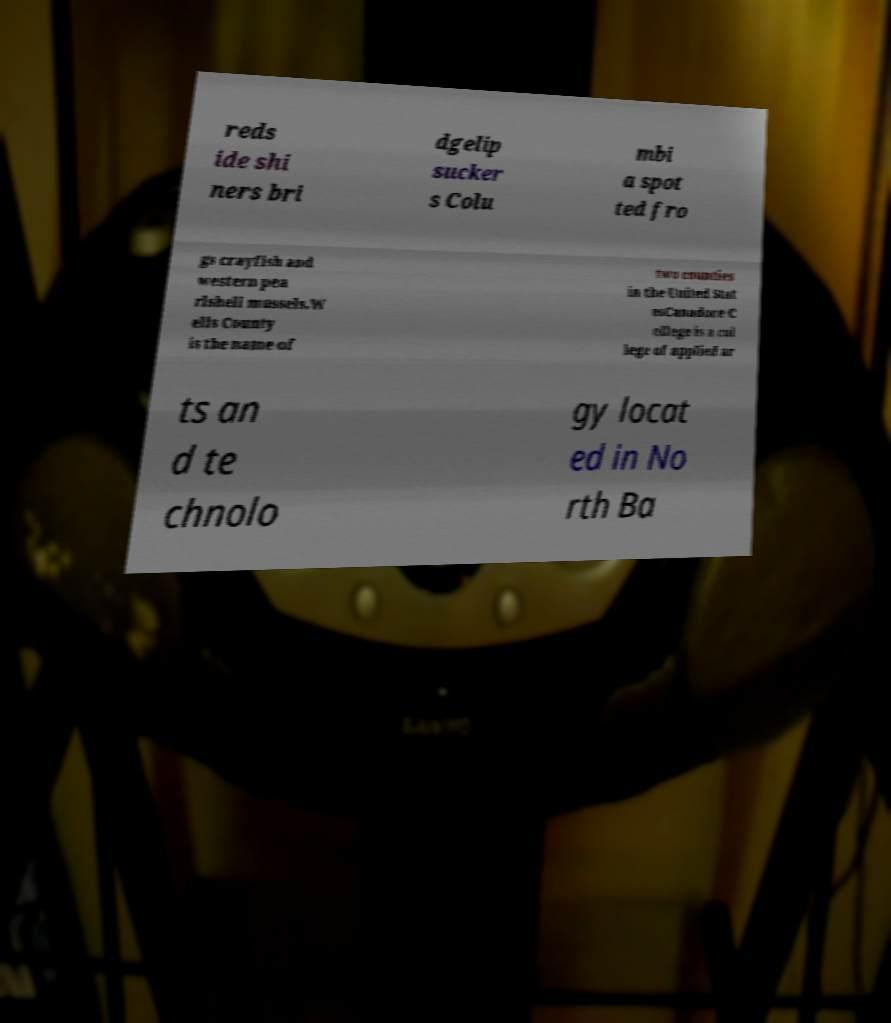Can you accurately transcribe the text from the provided image for me? reds ide shi ners bri dgelip sucker s Colu mbi a spot ted fro gs crayfish and western pea rlshell mussels.W ells County is the name of two counties in the United Stat esCanadore C ollege is a col lege of applied ar ts an d te chnolo gy locat ed in No rth Ba 